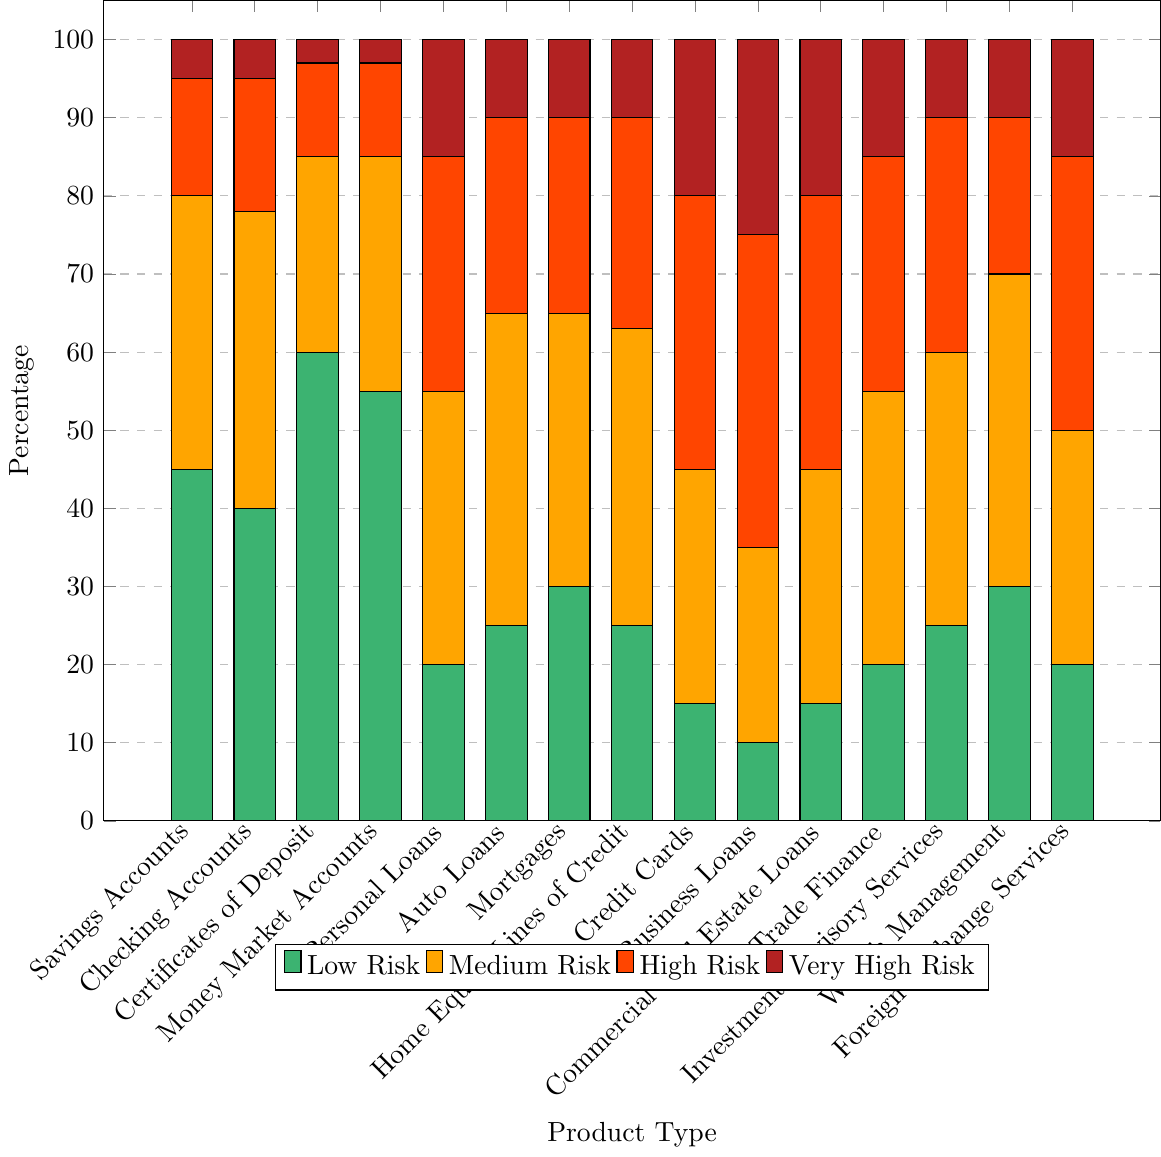which financial product has the highest percentage of low risk? By inspecting the figure, observe that Certificates of Deposit has the tallest green bar in the Low Risk category.
Answer: Certificates of Deposit which two products have the same percentage of very high risk? By inspecting the height of the red bars, both Savings Accounts and Checking Accounts have equal heights in the Very High Risk category.
Answer: Savings Accounts and Checking Accounts compare the medium risk percentages of Credit Cards and Business Loans Look at the height of the orange bars for both products; Credit Cards has a higher percentage than Business Loans in the Medium Risk category.
Answer: Credit Cards has a higher medium risk percentage what's the total percentage of Savings Accounts considered low or medium risk? Sum the values of the green and orange bars for Savings Accounts: 45 (Low Risk) + 35 (Medium Risk).
Answer: 80% which product type has the lowest percentage of low risk? Observe the smallest green bar across all product types, which belongs to Business Loans.
Answer: Business Loans compare the high risk percentages of Mortgages and Trade Finance, and determine the difference Mortgages and Trade Finance have 25% and 30% for high risk, respectively. The difference is 30 - 25.
Answer: 5% calculate the average percentage of low risk across all product types Sum all the percentages in the Low Risk category and divide by the number of products: (45 + 40 + 60 + 55 + 20 + 25 + 30 + 25 + 15 + 10 + 15 + 20 + 25 + 30 + 20) / 15
Answer: 30% which product type has the widest range between its highest and lowest risk categories? For each product, subtract the smallest bar from the tallest bar. Credit Cards range from 15% (Low Risk) to 35% (High Risk), so range = 35 - 15 = 20. Do this for all and see that Credit Cards have the widest range.
Answer: Credit Cards what's the combined percentage of very high risk across all financial products? Sum all the percentages in the Very High Risk category for every product: (5 + 5 + 3 + 3 + 15 + 10 + 10 + 10 + 20 + 25 + 20 + 15 + 10 + 10 + 15)
Answer: 176% 